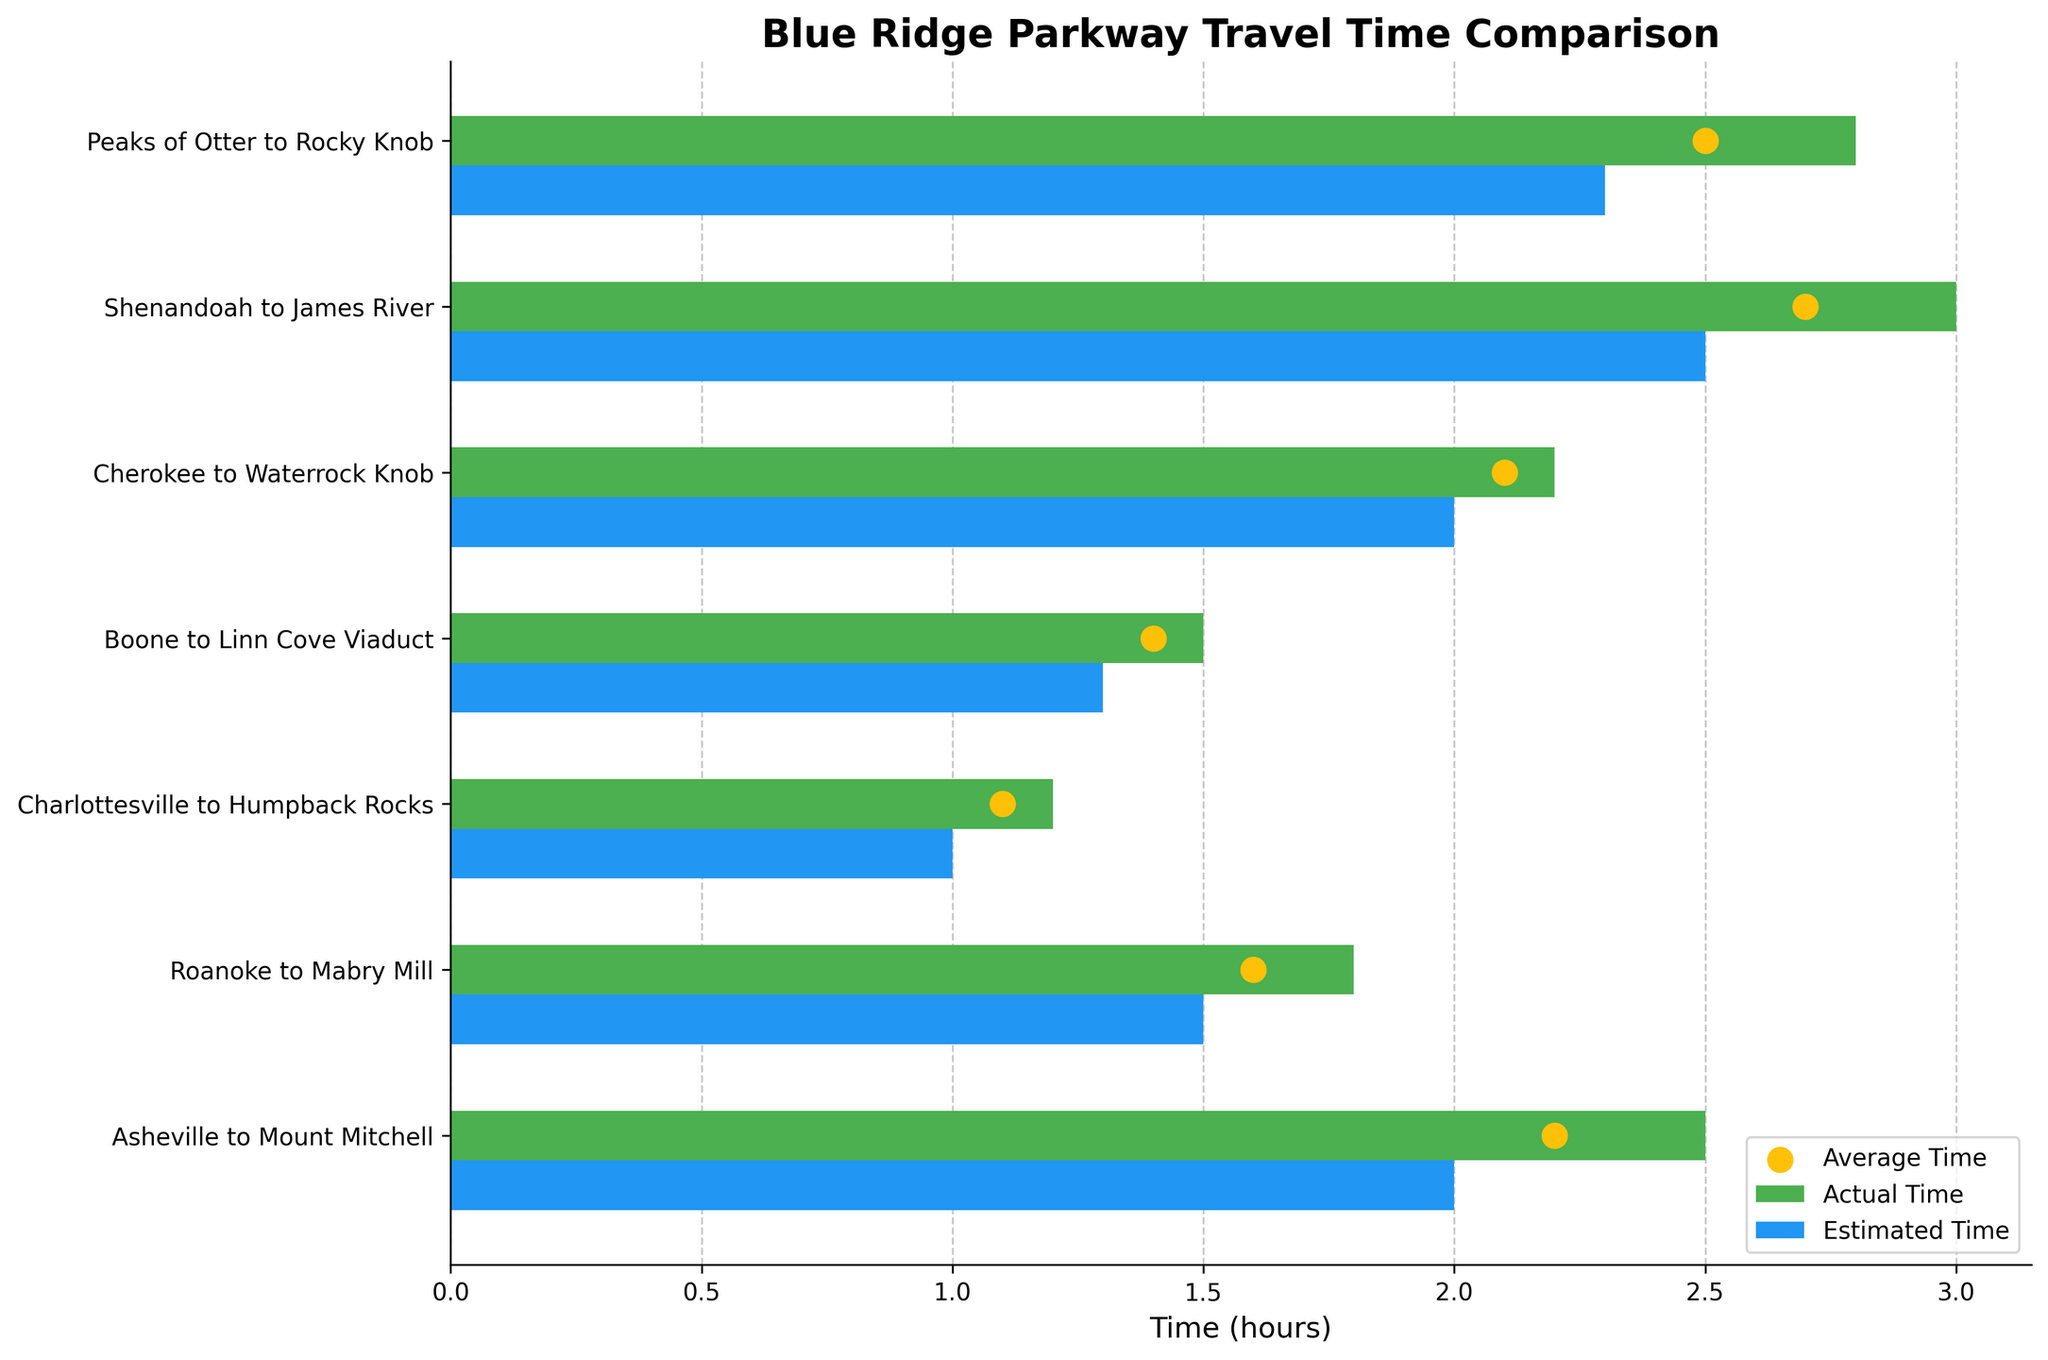What is the title of the chart? The title is typically positioned at the top of a chart and is written in a larger font to stand out.
Answer: Blue Ridge Parkway Travel Time Comparison Which segment has the longest actual travel time? The segment with the longest actual travel time is identified by the longest bar representing the actual travel time.
Answer: Shenandoah to James River How does the actual travel time for Roanoke to Mabry Mill compare to its estimated travel time? You can compare the lengths of the green (actual) and blue (estimated) bars for the segment Roanoke to Mabry Mill. The green bar is slightly longer.
Answer: Actual is longer Which segment has the smallest difference between actual and estimated travel time? Locate the segment where the lengths of the actual and estimated time bars are the closest to each other, indicating the smallest difference.
Answer: Charlottesville to Humpback Rocks What is the average travel time for the Boone to Linn Cove Viaduct segment? Identify the yellow dot for the Boone to Linn Cove Viaduct segment, which represents the average travel time, to find the value.
Answer: 1.4 hours How many segments have an actual travel time that exceeds their estimated travel time? Count the number of segments where the green bar (actual time) is longer than the blue bar (estimated time).
Answer: 6 segments Which segment has the highest average travel time? Look for the highest placed yellow dot across all segments to identify the segment with the highest average travel time.
Answer: Shenandoah to James River Between Cherokee to Waterrock Knob and Peaks of Otter to Rocky Knob, which has a smaller difference between actual and estimated times? Compare the differences between the lengths of the green and blue bars for both these segments; the smaller difference indicates the required segment.
Answer: Cherokee to Waterrock Knob Is there any segment where the estimated travel time is more than the actual travel time? Check if there is any segment for which the blue bar (estimated time) is longer than the green bar (actual time).
Answer: No What is the range of actual travel times displayed on the chart? Identify the shortest and longest actual travel time bars to determine the minimum and maximum values.
Answer: 1.2 hours to 3 hours 